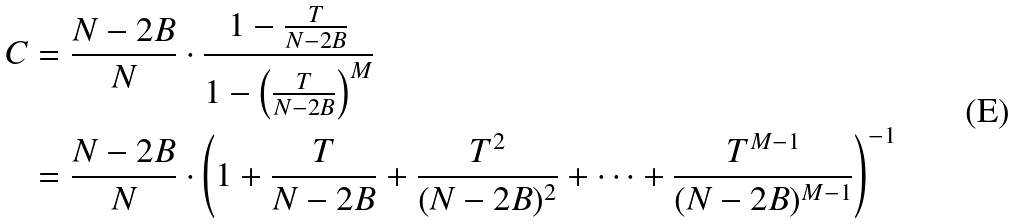<formula> <loc_0><loc_0><loc_500><loc_500>C & = \frac { N - 2 B } { N } \cdot \frac { 1 - \frac { T } { N - 2 B } } { 1 - \left ( \frac { T } { N - 2 B } \right ) ^ { M } } \\ & = \frac { N - 2 B } { N } \cdot \left ( 1 + \frac { T } { N - 2 B } + \frac { T ^ { 2 } } { ( N - 2 B ) ^ { 2 } } + \cdots + \frac { T ^ { M - 1 } } { ( N - 2 B ) ^ { M - 1 } } \right ) ^ { - 1 }</formula> 